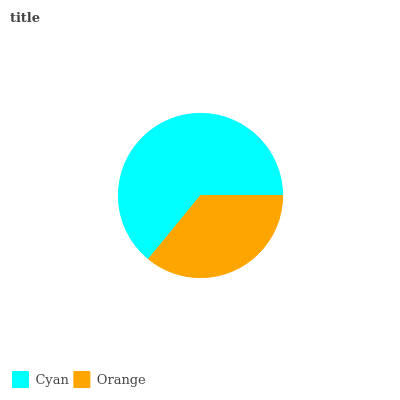Is Orange the minimum?
Answer yes or no. Yes. Is Cyan the maximum?
Answer yes or no. Yes. Is Orange the maximum?
Answer yes or no. No. Is Cyan greater than Orange?
Answer yes or no. Yes. Is Orange less than Cyan?
Answer yes or no. Yes. Is Orange greater than Cyan?
Answer yes or no. No. Is Cyan less than Orange?
Answer yes or no. No. Is Cyan the high median?
Answer yes or no. Yes. Is Orange the low median?
Answer yes or no. Yes. Is Orange the high median?
Answer yes or no. No. Is Cyan the low median?
Answer yes or no. No. 